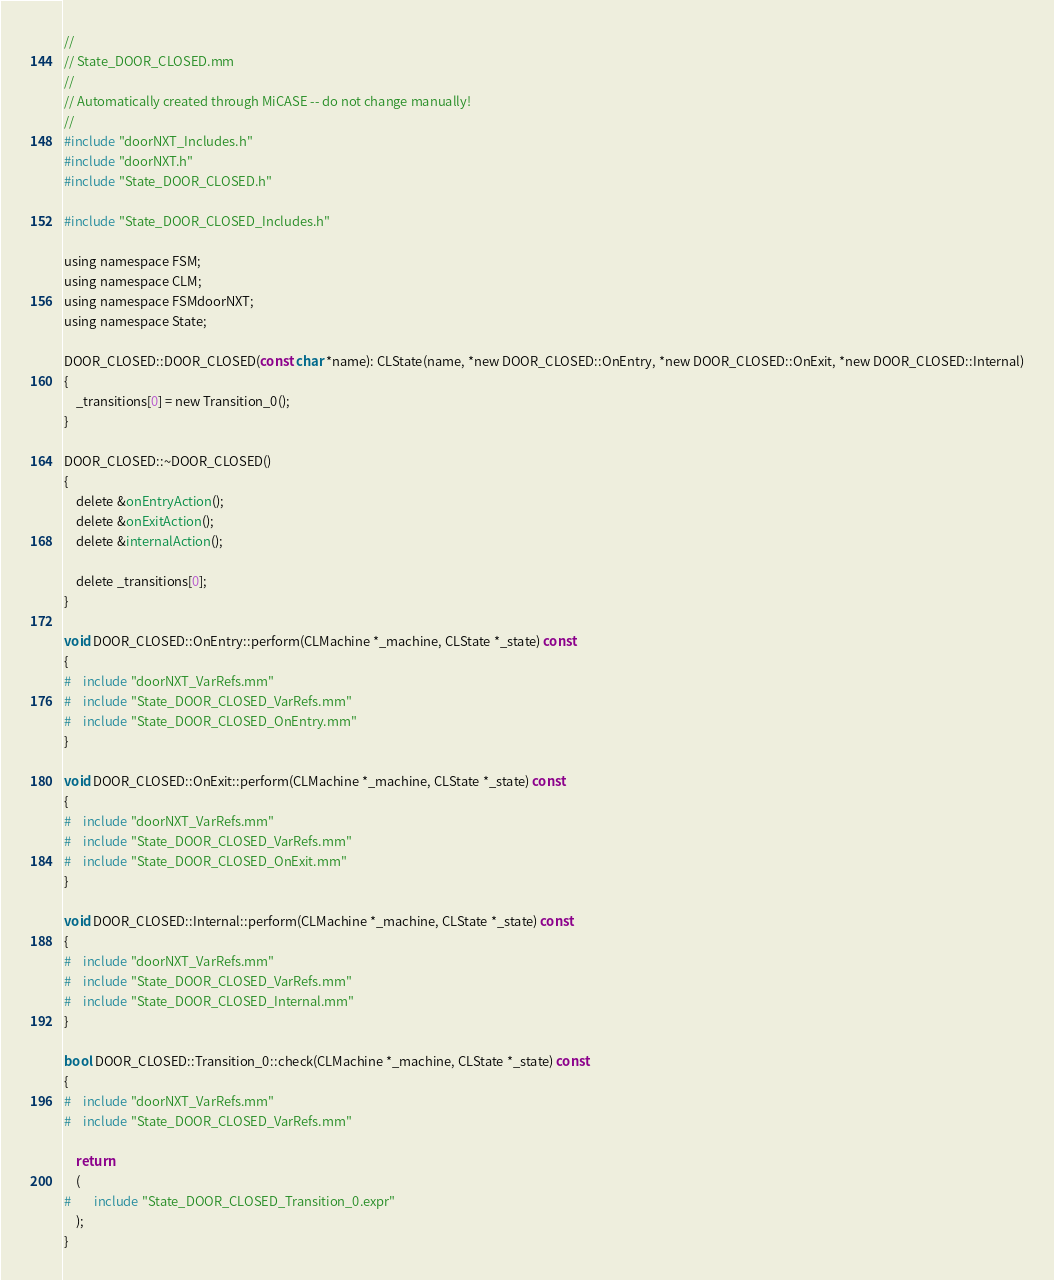<code> <loc_0><loc_0><loc_500><loc_500><_ObjectiveC_>//
// State_DOOR_CLOSED.mm
//
// Automatically created through MiCASE -- do not change manually!
//
#include "doorNXT_Includes.h"
#include "doorNXT.h"
#include "State_DOOR_CLOSED.h"

#include "State_DOOR_CLOSED_Includes.h"

using namespace FSM;
using namespace CLM;
using namespace FSMdoorNXT;
using namespace State;

DOOR_CLOSED::DOOR_CLOSED(const char *name): CLState(name, *new DOOR_CLOSED::OnEntry, *new DOOR_CLOSED::OnExit, *new DOOR_CLOSED::Internal)
{
	_transitions[0] = new Transition_0();
}

DOOR_CLOSED::~DOOR_CLOSED()
{
	delete &onEntryAction();
	delete &onExitAction();
	delete &internalAction();

	delete _transitions[0];
}

void DOOR_CLOSED::OnEntry::perform(CLMachine *_machine, CLState *_state) const
{
#	include "doorNXT_VarRefs.mm"
#	include "State_DOOR_CLOSED_VarRefs.mm"
#	include "State_DOOR_CLOSED_OnEntry.mm"
}

void DOOR_CLOSED::OnExit::perform(CLMachine *_machine, CLState *_state) const
{
#	include "doorNXT_VarRefs.mm"
#	include "State_DOOR_CLOSED_VarRefs.mm"
#	include "State_DOOR_CLOSED_OnExit.mm"
}

void DOOR_CLOSED::Internal::perform(CLMachine *_machine, CLState *_state) const
{
#	include "doorNXT_VarRefs.mm"
#	include "State_DOOR_CLOSED_VarRefs.mm"
#	include "State_DOOR_CLOSED_Internal.mm"
}

bool DOOR_CLOSED::Transition_0::check(CLMachine *_machine, CLState *_state) const
{
#	include "doorNXT_VarRefs.mm"
#	include "State_DOOR_CLOSED_VarRefs.mm"

	return
	(
#		include "State_DOOR_CLOSED_Transition_0.expr"
	);
}
</code> 